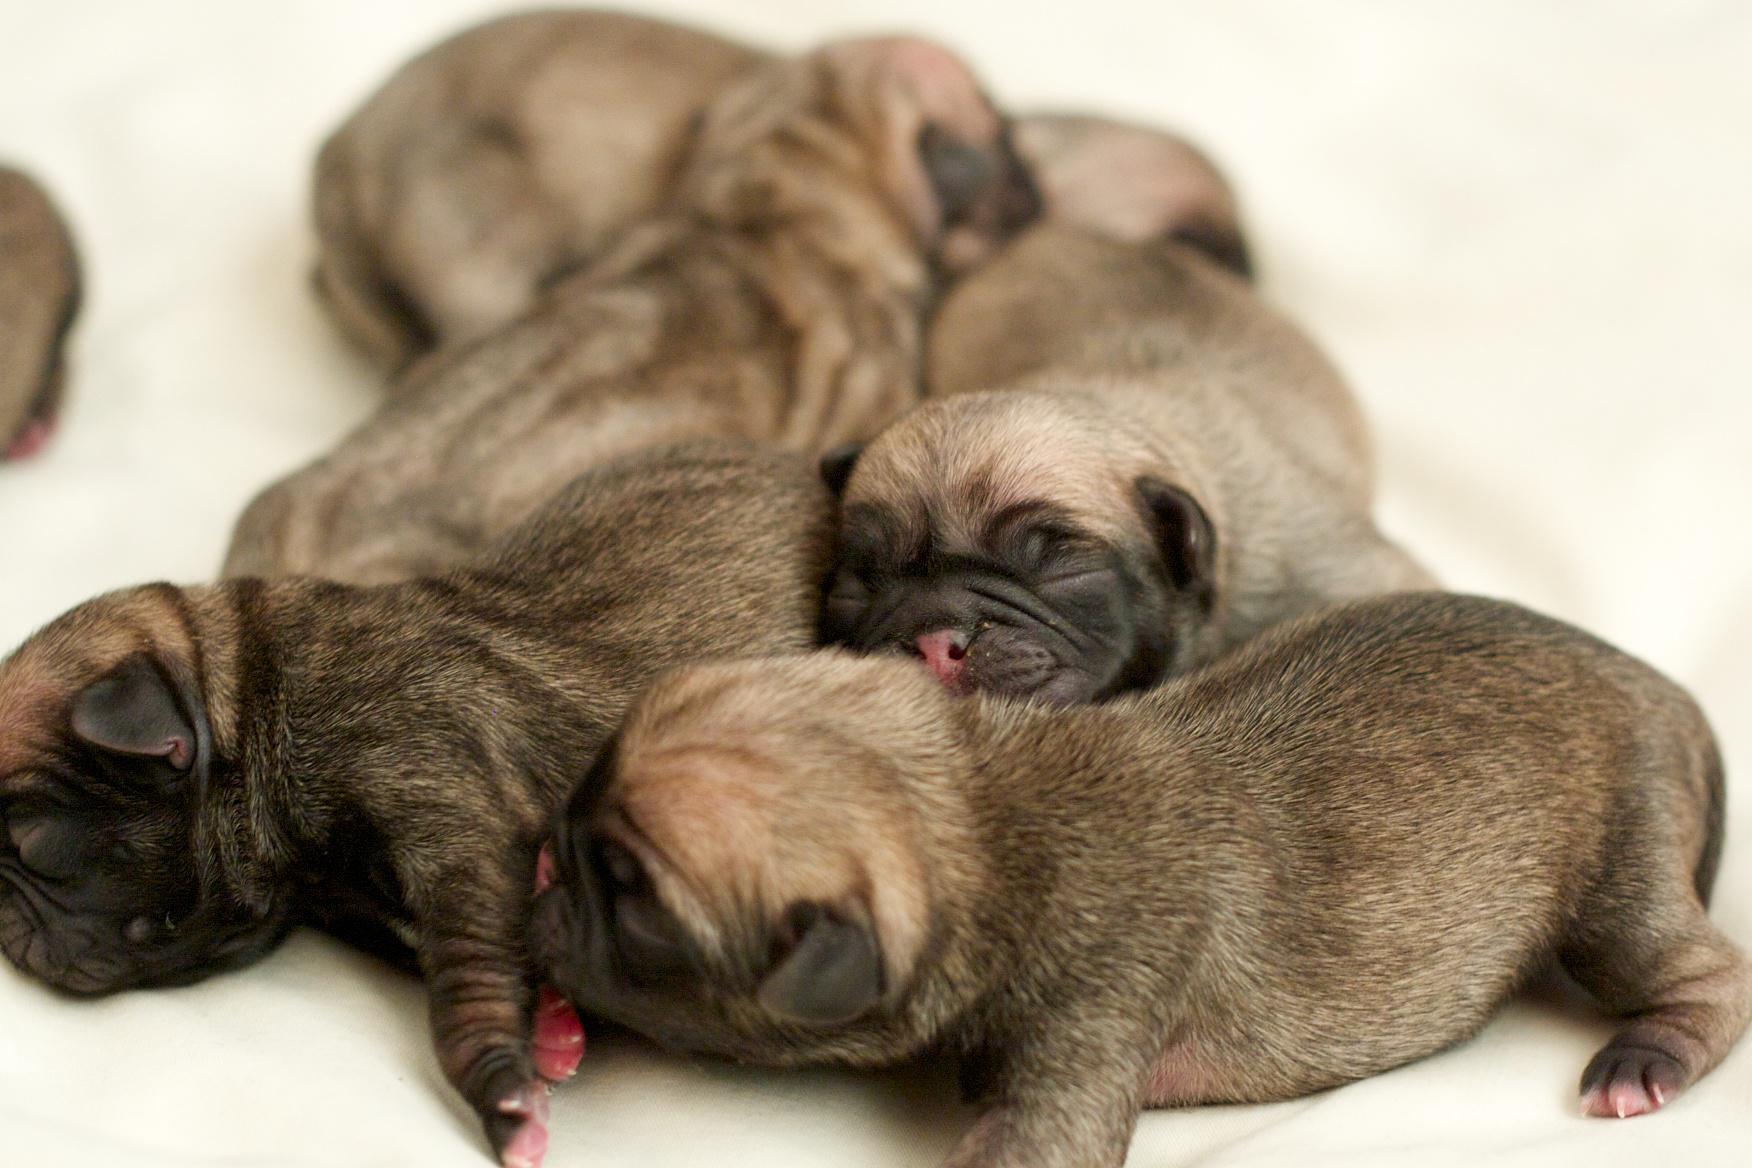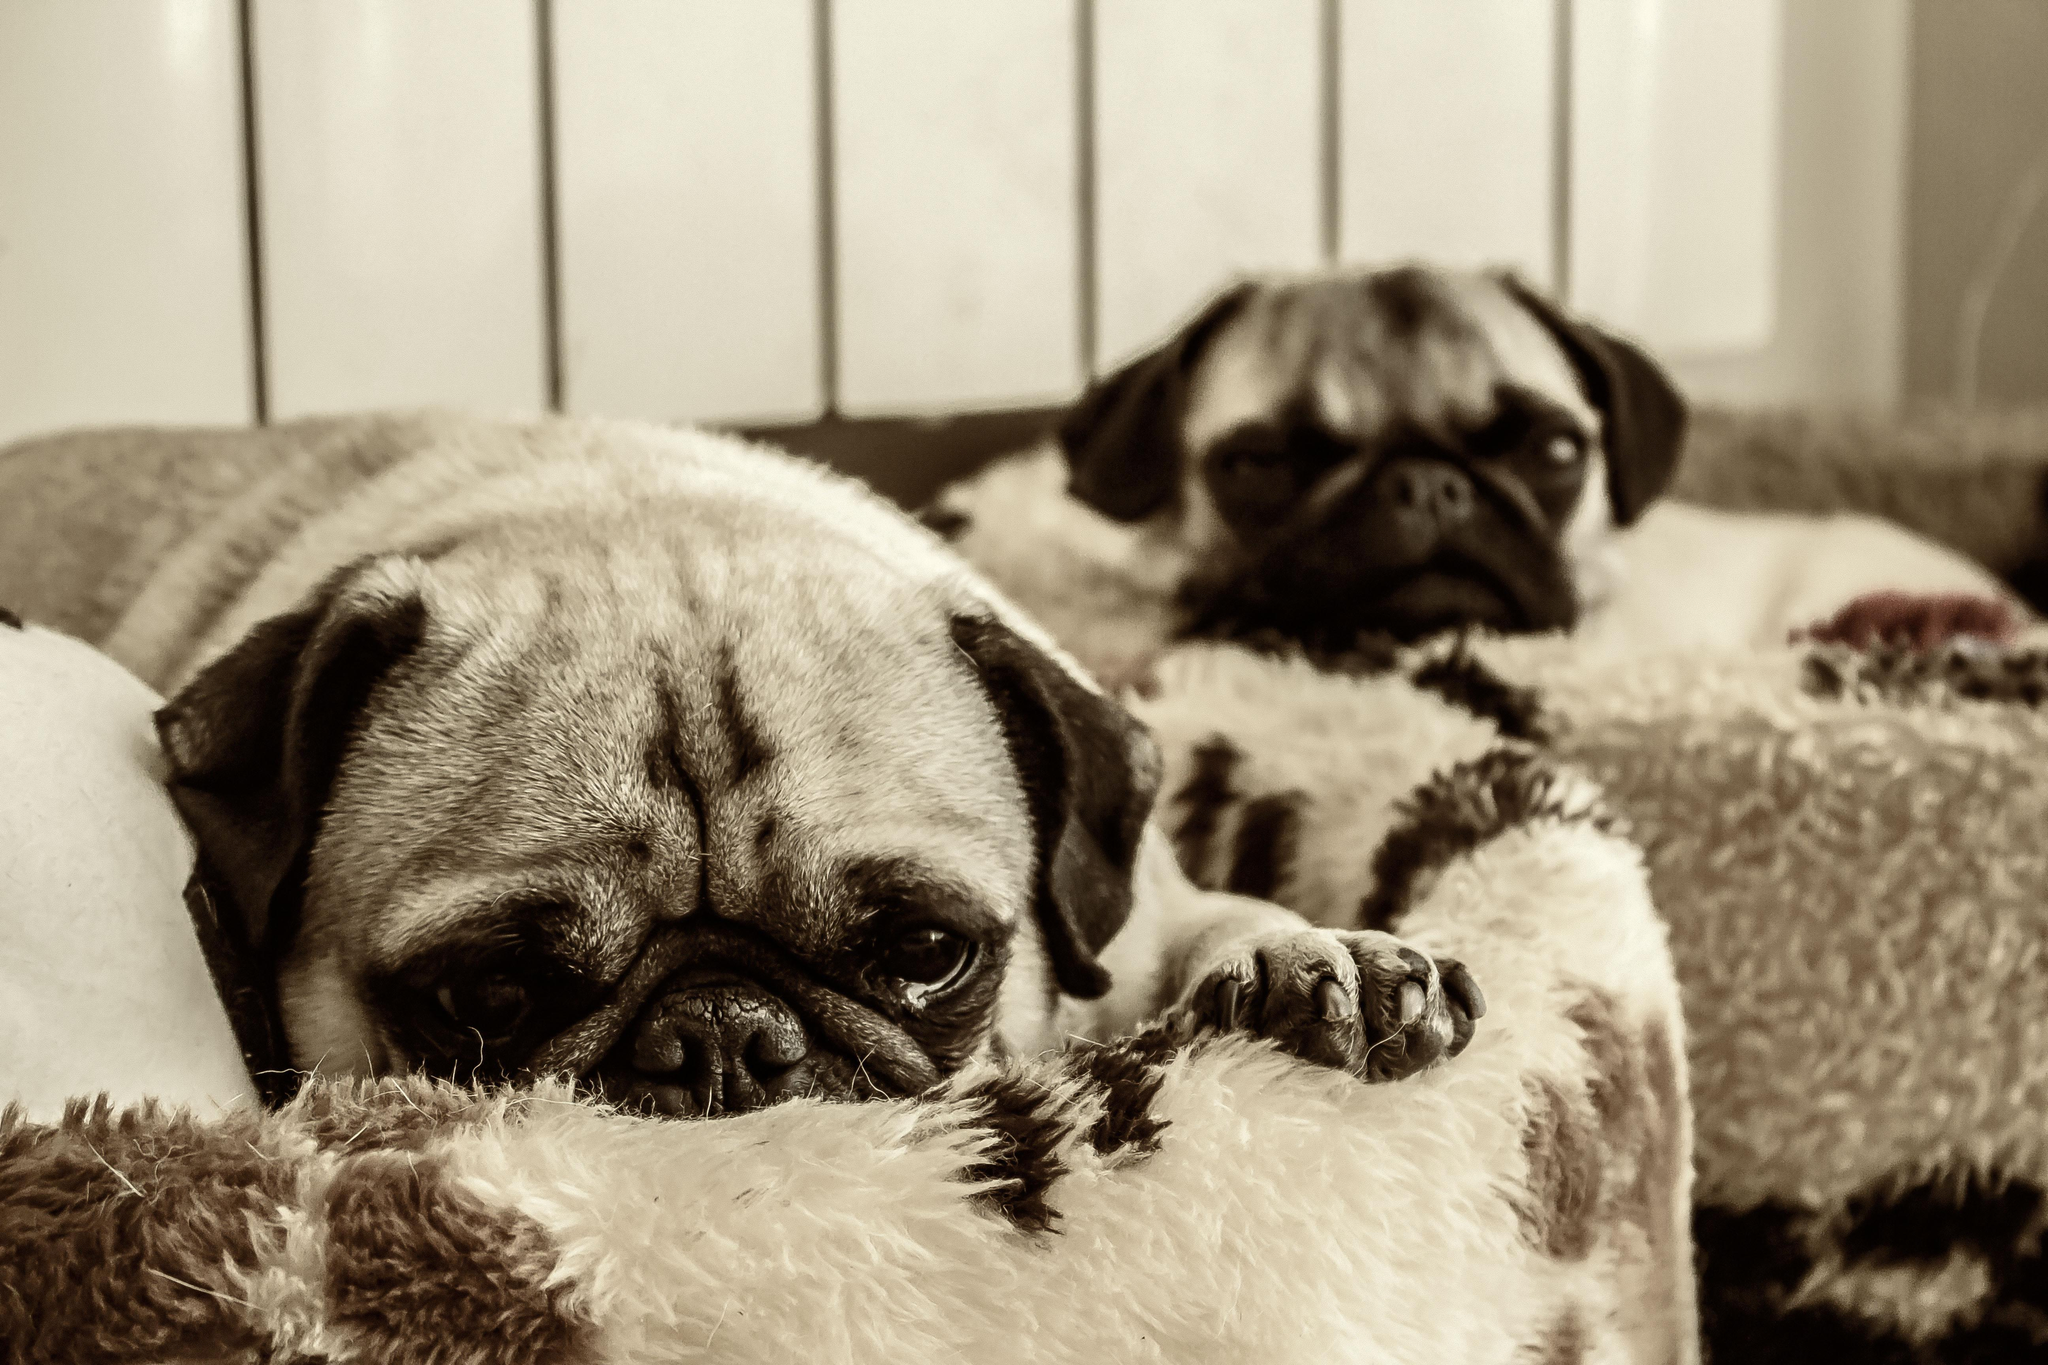The first image is the image on the left, the second image is the image on the right. Considering the images on both sides, is "The left image contains at least two dogs." valid? Answer yes or no. Yes. The first image is the image on the left, the second image is the image on the right. Examine the images to the left and right. Is the description "There are exactly 3 dogs depicted." accurate? Answer yes or no. No. 